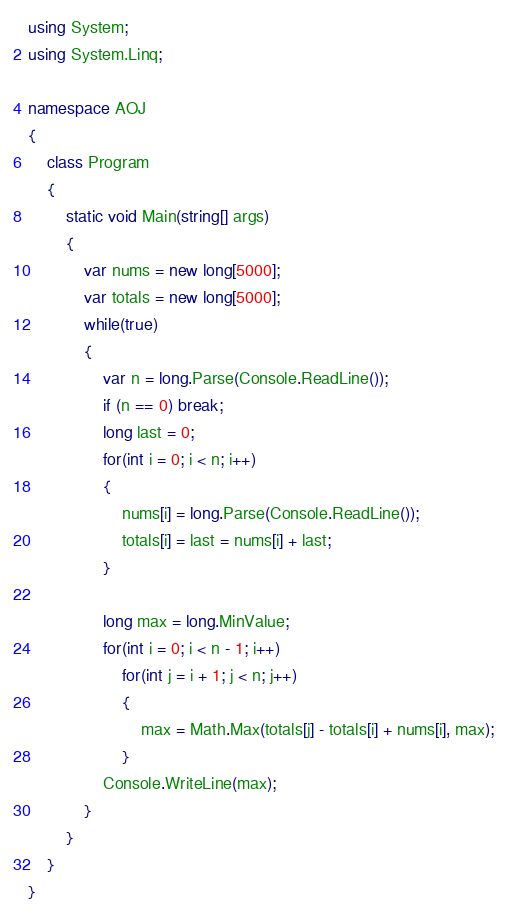<code> <loc_0><loc_0><loc_500><loc_500><_C#_>using System;
using System.Linq;

namespace AOJ
{
    class Program
    {
        static void Main(string[] args)
        {
            var nums = new long[5000];
            var totals = new long[5000];
            while(true)
            {
                var n = long.Parse(Console.ReadLine());
                if (n == 0) break;
                long last = 0;
                for(int i = 0; i < n; i++)
                {
                    nums[i] = long.Parse(Console.ReadLine());
                    totals[i] = last = nums[i] + last;
                }

                long max = long.MinValue;
                for(int i = 0; i < n - 1; i++)
                    for(int j = i + 1; j < n; j++)
                    {
                        max = Math.Max(totals[j] - totals[i] + nums[i], max);
                    }
                Console.WriteLine(max);
            }
        }
    }
}</code> 